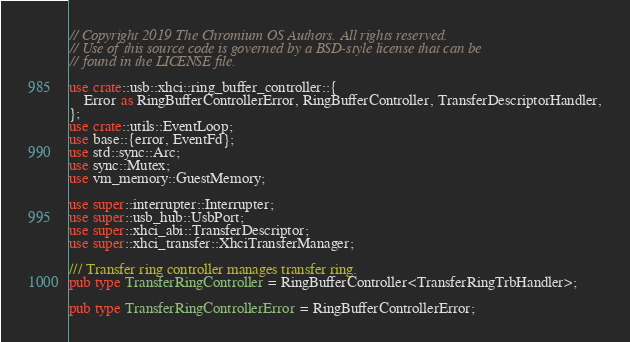<code> <loc_0><loc_0><loc_500><loc_500><_Rust_>// Copyright 2019 The Chromium OS Authors. All rights reserved.
// Use of this source code is governed by a BSD-style license that can be
// found in the LICENSE file.

use crate::usb::xhci::ring_buffer_controller::{
    Error as RingBufferControllerError, RingBufferController, TransferDescriptorHandler,
};
use crate::utils::EventLoop;
use base::{error, EventFd};
use std::sync::Arc;
use sync::Mutex;
use vm_memory::GuestMemory;

use super::interrupter::Interrupter;
use super::usb_hub::UsbPort;
use super::xhci_abi::TransferDescriptor;
use super::xhci_transfer::XhciTransferManager;

/// Transfer ring controller manages transfer ring.
pub type TransferRingController = RingBufferController<TransferRingTrbHandler>;

pub type TransferRingControllerError = RingBufferControllerError;
</code> 